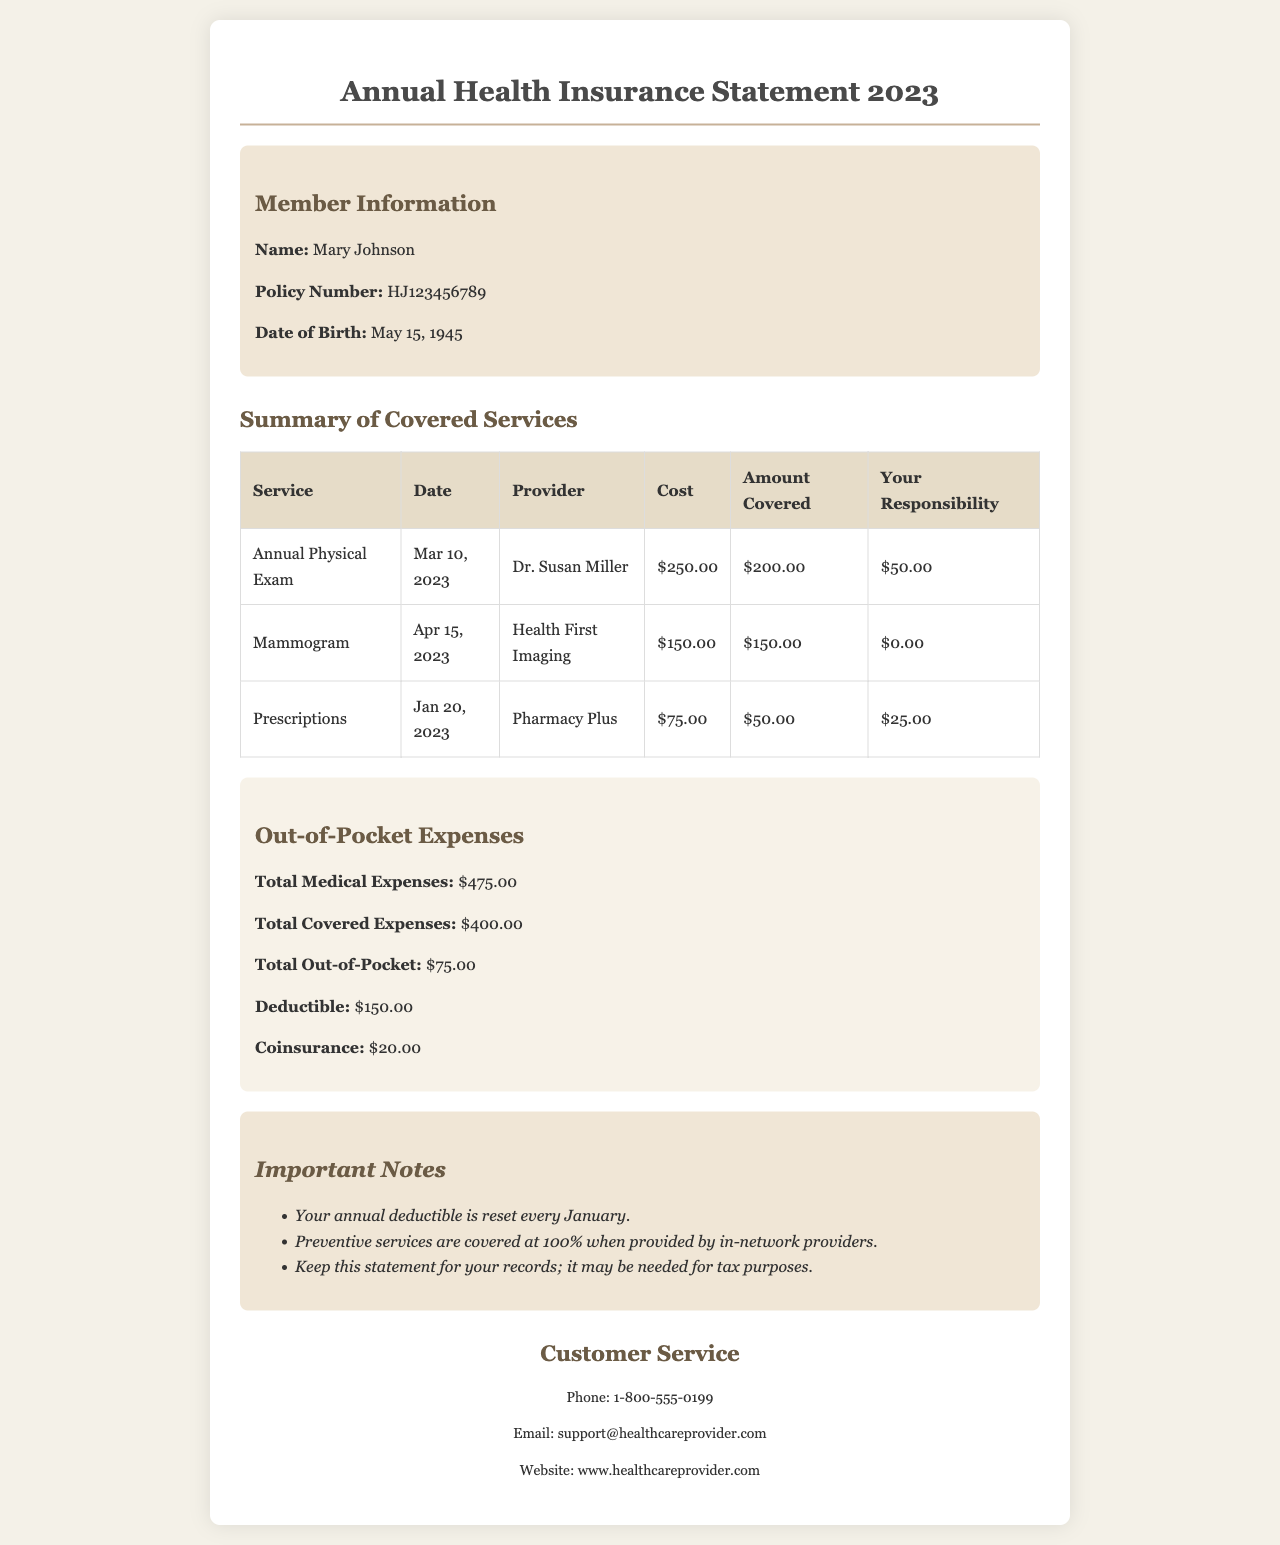What is the name of the member? The member's name is listed in the member information section of the document.
Answer: Mary Johnson What was the date of the Annual Physical Exam? The date can be found in the summary of covered services under the service of Annual Physical Exam.
Answer: Mar 10, 2023 How much did Dr. Susan Miller charge for the Annual Physical Exam? The cost for the service is mentioned in the table under the 'Cost' column for the Annual Physical Exam.
Answer: $250.00 What is the total out-of-pocket expense? The total out-of-pocket expense is specified in the out-of-pocket expenses section.
Answer: $75.00 What is the deductible amount? The deductible amount can be found in the out-of-pocket expenses section of the document.
Answer: $150.00 How much was covered for the mammogram? The amount covered for the service is shown in the summary table under the 'Amount Covered' column for the mammogram.
Answer: $150.00 What does the document say about preventive services? The important notes section includes specifics about preventive services.
Answer: Covered at 100% What is the contact phone number for customer service? The contact information for customer service is located at the bottom of the document.
Answer: 1-800-555-0199 What is the total medical expense for the year? The total medical expenses amount is listed in the out-of-pocket expenses section.
Answer: $475.00 